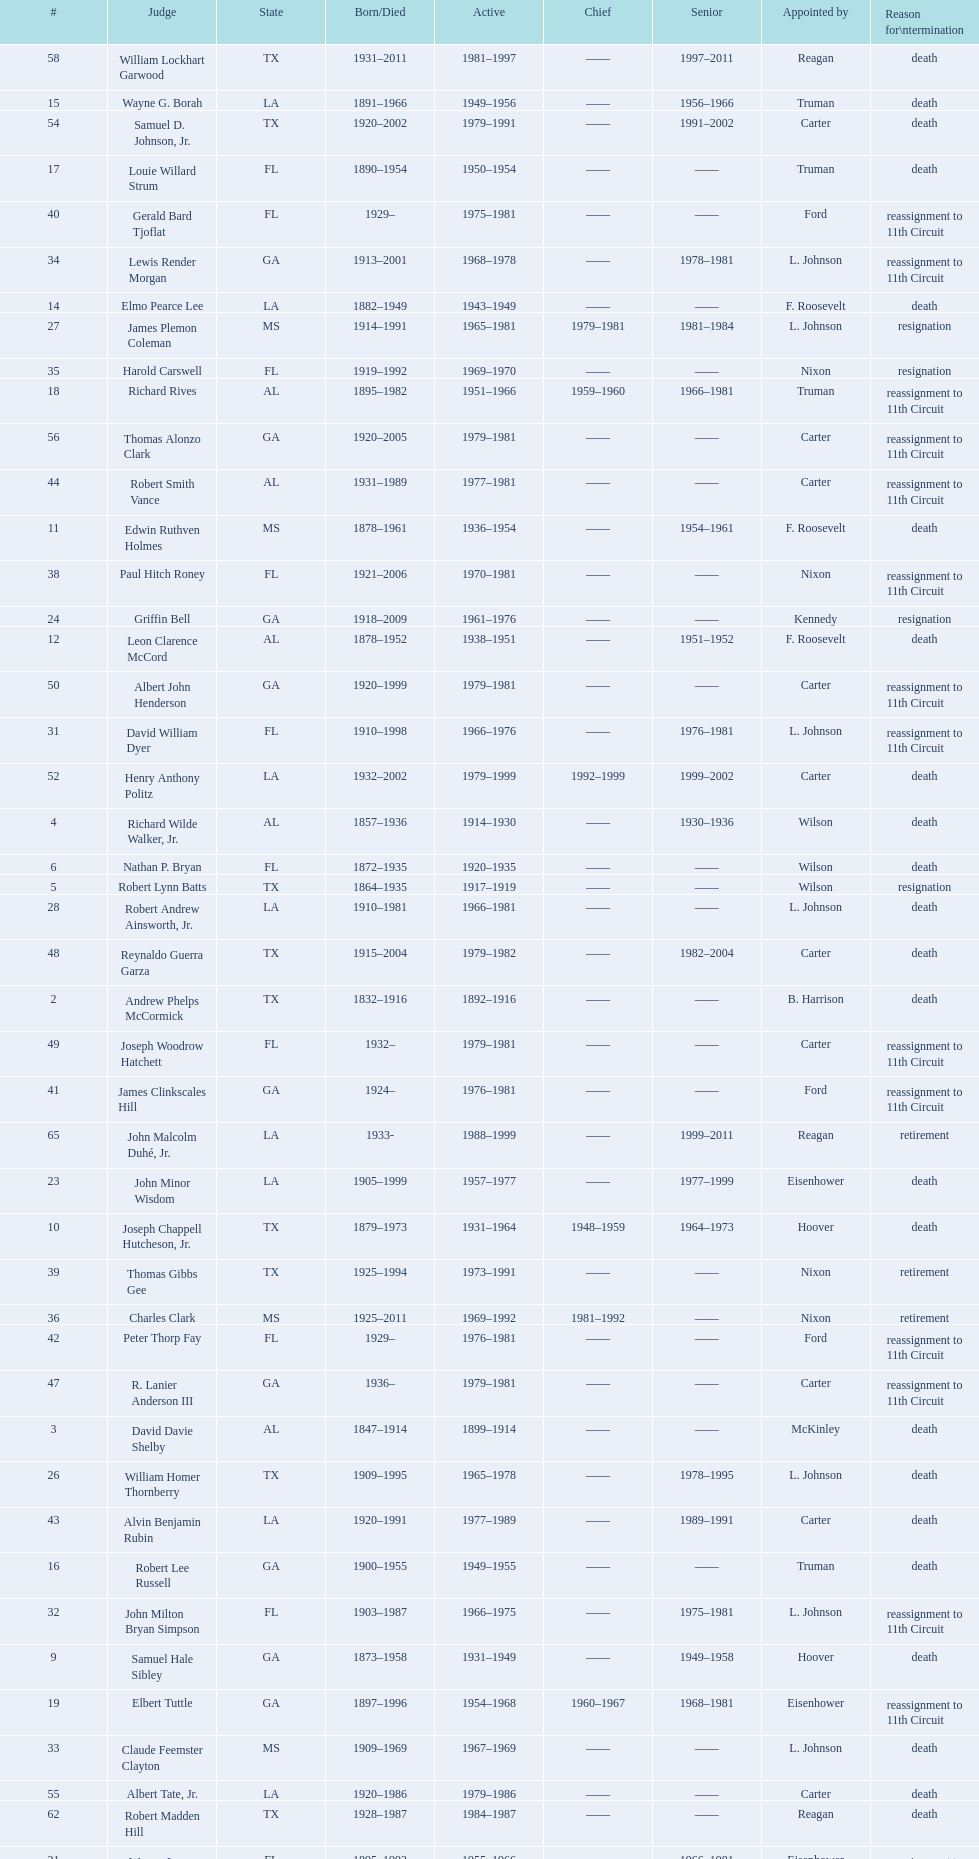Who was the first judge from florida to serve the position? Nathan P. Bryan. 